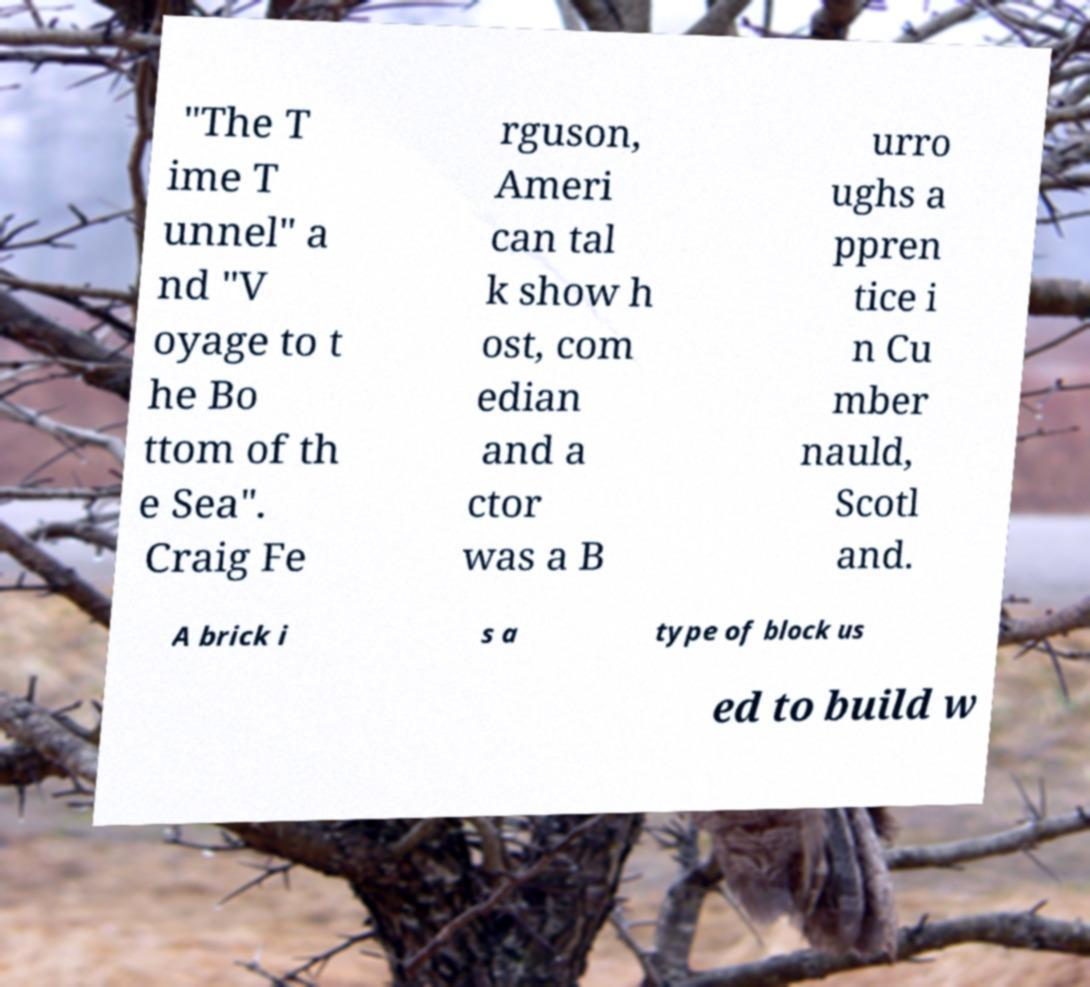For documentation purposes, I need the text within this image transcribed. Could you provide that? "The T ime T unnel" a nd "V oyage to t he Bo ttom of th e Sea". Craig Fe rguson, Ameri can tal k show h ost, com edian and a ctor was a B urro ughs a ppren tice i n Cu mber nauld, Scotl and. A brick i s a type of block us ed to build w 